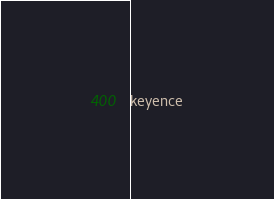Convert code to text. <code><loc_0><loc_0><loc_500><loc_500><_Scheme_>keyence
</code> 